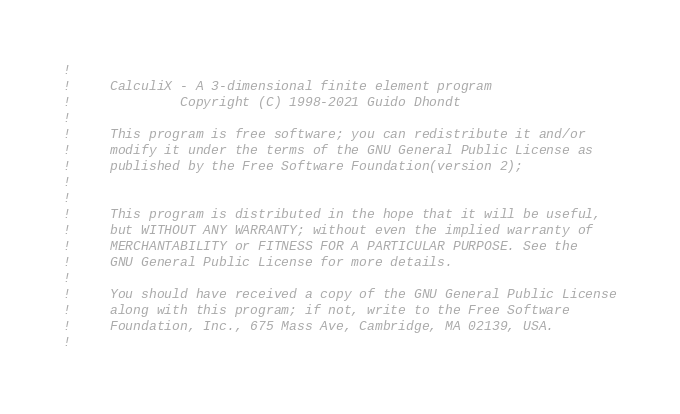Convert code to text. <code><loc_0><loc_0><loc_500><loc_500><_FORTRAN_>!
!     CalculiX - A 3-dimensional finite element program
!              Copyright (C) 1998-2021 Guido Dhondt
!
!     This program is free software; you can redistribute it and/or
!     modify it under the terms of the GNU General Public License as
!     published by the Free Software Foundation(version 2);
!     
!
!     This program is distributed in the hope that it will be useful,
!     but WITHOUT ANY WARRANTY; without even the implied warranty of 
!     MERCHANTABILITY or FITNESS FOR A PARTICULAR PURPOSE. See the 
!     GNU General Public License for more details.
!
!     You should have received a copy of the GNU General Public License
!     along with this program; if not, write to the Free Software
!     Foundation, Inc., 675 Mass Ave, Cambridge, MA 02139, USA.
!</code> 